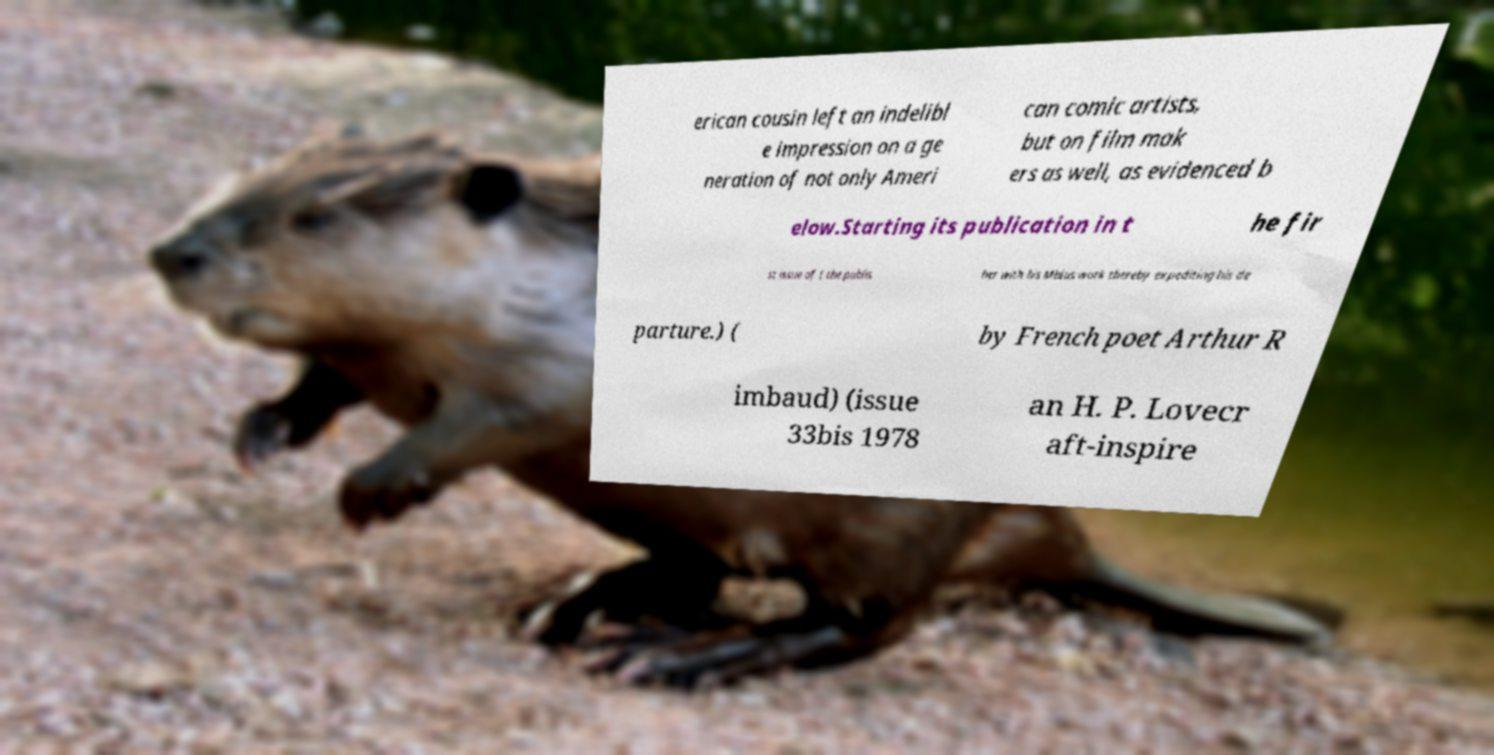Please read and relay the text visible in this image. What does it say? erican cousin left an indelibl e impression on a ge neration of not only Ameri can comic artists, but on film mak ers as well, as evidenced b elow.Starting its publication in t he fir st issue of ( the publis her with his Mbius work thereby expediting his de parture.) ( by French poet Arthur R imbaud) (issue 33bis 1978 an H. P. Lovecr aft-inspire 